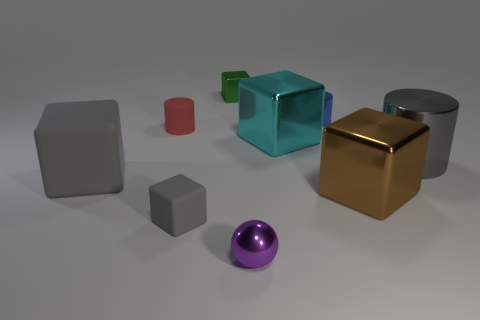Subtract all green cylinders. How many gray cubes are left? 2 Subtract all tiny gray matte blocks. How many blocks are left? 4 Subtract all cyan blocks. How many blocks are left? 4 Subtract 1 cylinders. How many cylinders are left? 2 Subtract all spheres. How many objects are left? 8 Subtract all red cubes. Subtract all gray cylinders. How many cubes are left? 5 Add 2 large purple metal spheres. How many large purple metal spheres exist? 2 Subtract 0 cyan cylinders. How many objects are left? 9 Subtract all small green objects. Subtract all big brown cubes. How many objects are left? 7 Add 5 red rubber cylinders. How many red rubber cylinders are left? 6 